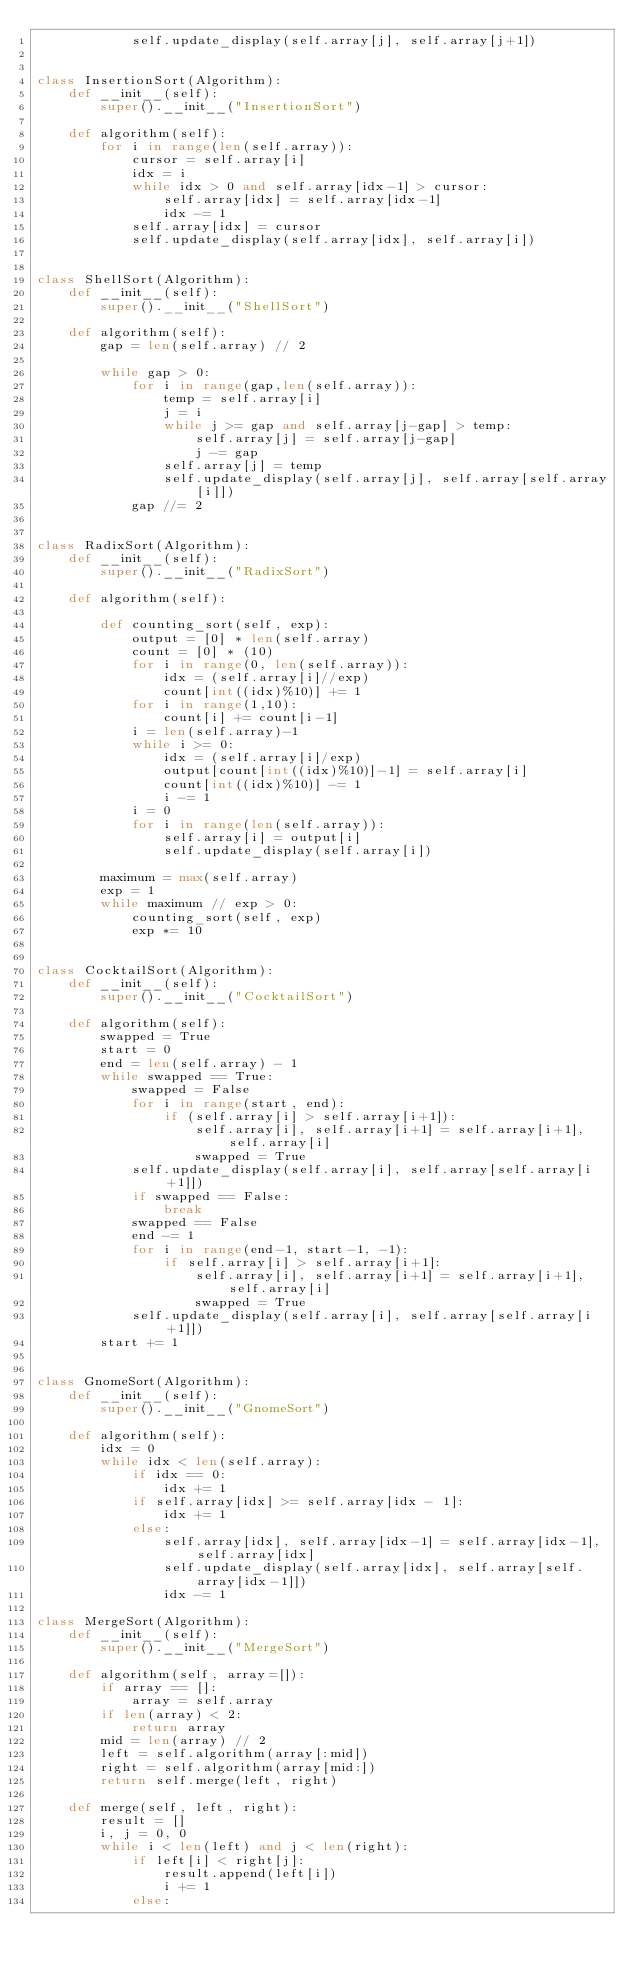<code> <loc_0><loc_0><loc_500><loc_500><_Python_>            self.update_display(self.array[j], self.array[j+1])


class InsertionSort(Algorithm):
    def __init__(self):
        super().__init__("InsertionSort")

    def algorithm(self):
        for i in range(len(self.array)):
            cursor = self.array[i]
            idx = i
            while idx > 0 and self.array[idx-1] > cursor:
                self.array[idx] = self.array[idx-1]
                idx -= 1
            self.array[idx] = cursor
            self.update_display(self.array[idx], self.array[i])


class ShellSort(Algorithm):
    def __init__(self):
        super().__init__("ShellSort")

    def algorithm(self):
        gap = len(self.array) // 2

        while gap > 0:
            for i in range(gap,len(self.array)):
                temp = self.array[i]
                j = i
                while j >= gap and self.array[j-gap] > temp:
                    self.array[j] = self.array[j-gap]
                    j -= gap
                self.array[j] = temp
                self.update_display(self.array[j], self.array[self.array[i]])
            gap //= 2


class RadixSort(Algorithm):
    def __init__(self):
        super().__init__("RadixSort")

    def algorithm(self):

        def counting_sort(self, exp):
            output = [0] * len(self.array)
            count = [0] * (10)
            for i in range(0, len(self.array)):
                idx = (self.array[i]//exp)
                count[int((idx)%10)] += 1
            for i in range(1,10):
                count[i] += count[i-1]
            i = len(self.array)-1
            while i >= 0:
                idx = (self.array[i]/exp)
                output[count[int((idx)%10)]-1] = self.array[i]
                count[int((idx)%10)] -= 1
                i -= 1
            i = 0
            for i in range(len(self.array)):
                self.array[i] = output[i]
                self.update_display(self.array[i])

        maximum = max(self.array)
        exp = 1
        while maximum // exp > 0:
            counting_sort(self, exp)
            exp *= 10


class CocktailSort(Algorithm):
    def __init__(self):
        super().__init__("CocktailSort")

    def algorithm(self):
        swapped = True
        start = 0
        end = len(self.array) - 1
        while swapped == True:
            swapped = False
            for i in range(start, end):
                if (self.array[i] > self.array[i+1]):
                    self.array[i], self.array[i+1] = self.array[i+1], self.array[i]
                    swapped = True
            self.update_display(self.array[i], self.array[self.array[i+1]])
            if swapped == False:
                break
            swapped == False
            end -= 1
            for i in range(end-1, start-1, -1):
                if self.array[i] > self.array[i+1]:
                    self.array[i], self.array[i+1] = self.array[i+1], self.array[i]
                    swapped = True
            self.update_display(self.array[i], self.array[self.array[i+1]])
        start += 1


class GnomeSort(Algorithm):
    def __init__(self):
        super().__init__("GnomeSort")

    def algorithm(self):
        idx = 0
        while idx < len(self.array):
            if idx == 0:
                idx += 1
            if self.array[idx] >= self.array[idx - 1]:
                idx += 1
            else:
                self.array[idx], self.array[idx-1] = self.array[idx-1], self.array[idx]
                self.update_display(self.array[idx], self.array[self.array[idx-1]])
                idx -= 1

class MergeSort(Algorithm):
    def __init__(self):
        super().__init__("MergeSort")

    def algorithm(self, array=[]):
        if array == []:
            array = self.array
        if len(array) < 2:
            return array
        mid = len(array) // 2
        left = self.algorithm(array[:mid])
        right = self.algorithm(array[mid:])
        return self.merge(left, right)

    def merge(self, left, right):
        result = []
        i, j = 0, 0
        while i < len(left) and j < len(right):
            if left[i] < right[j]:
                result.append(left[i])
                i += 1
            else:</code> 